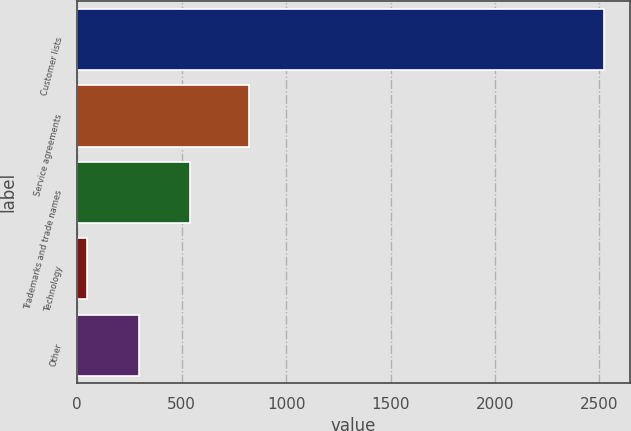Convert chart. <chart><loc_0><loc_0><loc_500><loc_500><bar_chart><fcel>Customer lists<fcel>Service agreements<fcel>Trademarks and trade names<fcel>Technology<fcel>Other<nl><fcel>2521<fcel>822<fcel>541<fcel>46<fcel>293.5<nl></chart> 